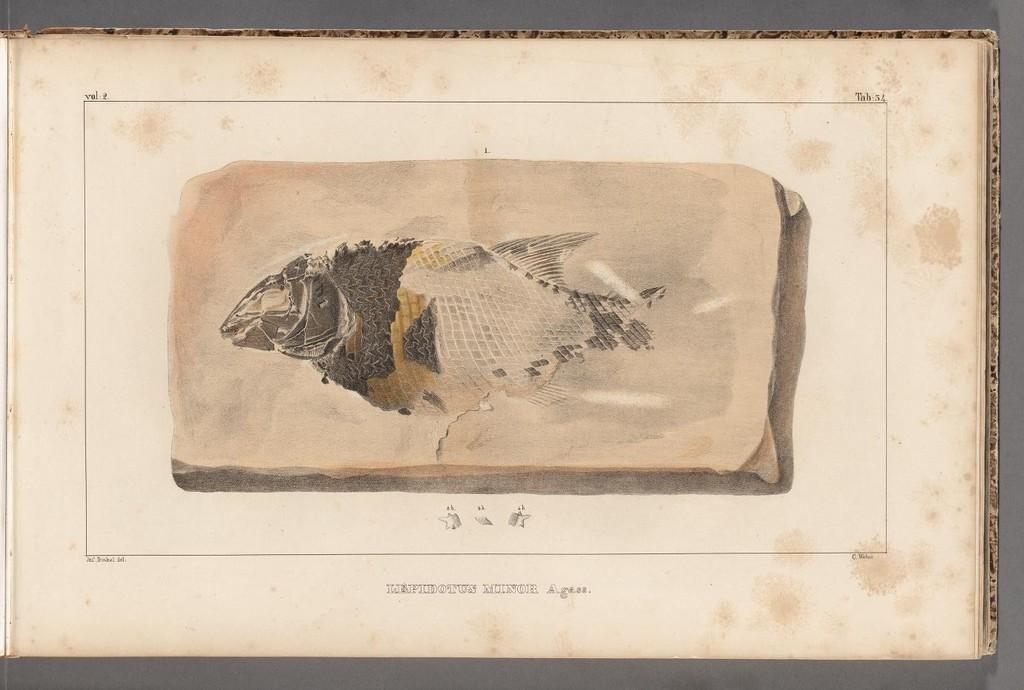What is the main subject of the image? The main subject of the image is a part of a fish. Where is the part of the fish located? The part of the fish is on a paper. What type of music can be heard playing in the background of the image? There is no music present in the image, as it only features a part of a fish on a paper. 